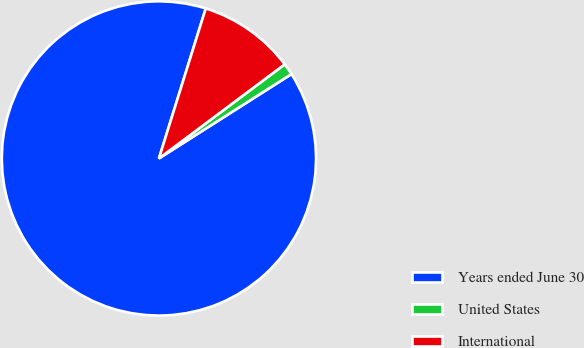<chart> <loc_0><loc_0><loc_500><loc_500><pie_chart><fcel>Years ended June 30<fcel>United States<fcel>International<nl><fcel>88.83%<fcel>1.2%<fcel>9.96%<nl></chart> 